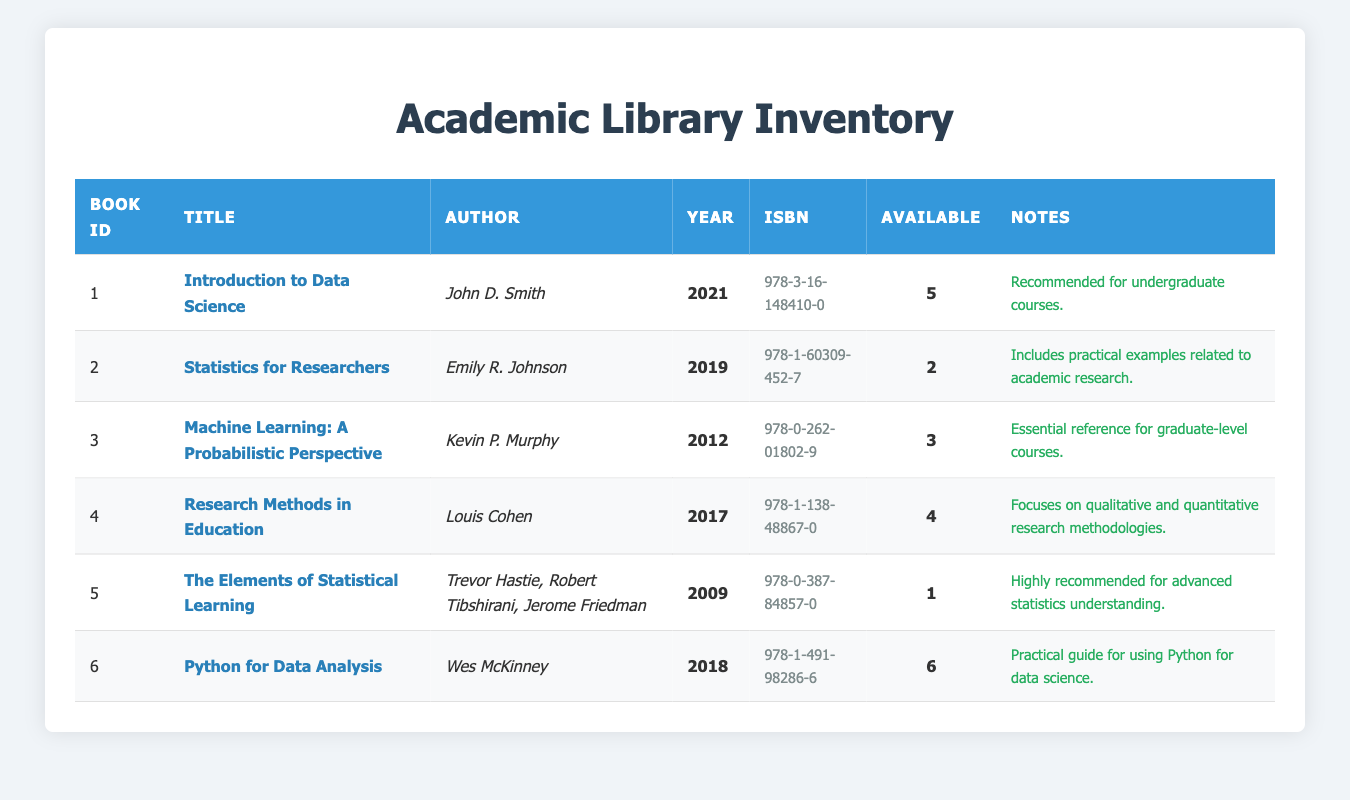What is the title of the book with the most available copies? Looking at the "Available" column, the book with the most copies is "Python for Data Analysis," which has 6 copies available.
Answer: Python for Data Analysis How many authors contributed to "The Elements of Statistical Learning"? The "Authors" column lists three names associated with "The Elements of Statistical Learning": Trevor Hastie, Robert Tibshirani, and Jerome Friedman. Therefore, three authors contributed to this book.
Answer: 3 Is there any book published before 2010 available in the library? By examining the "Year" column, "The Elements of Statistical Learning," published in 2009, is the only book listed that was published before 2010. Thus, there is a book published before 2010 available in the library.
Answer: Yes What is the average number of copies available for the listed books? To find the average, we sum all available copies: (5 + 2 + 3 + 4 + 1 + 6) = 21. Dividing that by the number of books, which is 6, gives us an average of 3.5 copies per book.
Answer: 3.5 Which book has the special note regarding its suitability for undergraduate courses? The table indicates that "Introduction to Data Science" has a special note stating it is recommended for undergraduate courses.
Answer: Introduction to Data Science How many books have 2 or fewer copies available? Reviewing the "Available" column again, only "Statistics for Researchers" (2 copies) and "The Elements of Statistical Learning" (1 copy) fit this criterion. Therefore, there are 2 books with 2 or fewer copies.
Answer: 2 What is the publication year of the book authored by Kevin P. Murphy? The table shows that "Machine Learning: A Probabilistic Perspective," authored by Kevin P. Murphy, was published in 2012.
Answer: 2012 Are there any books that focus solely on qualitative research methodologies? The note for "Research Methods in Education" mentions that it covers both qualitative and quantitative methodologies, but does not specify a focus on just qualitative methodologies. Therefore, there are no books focusing solely on qualitative research methodologies.
Answer: No 